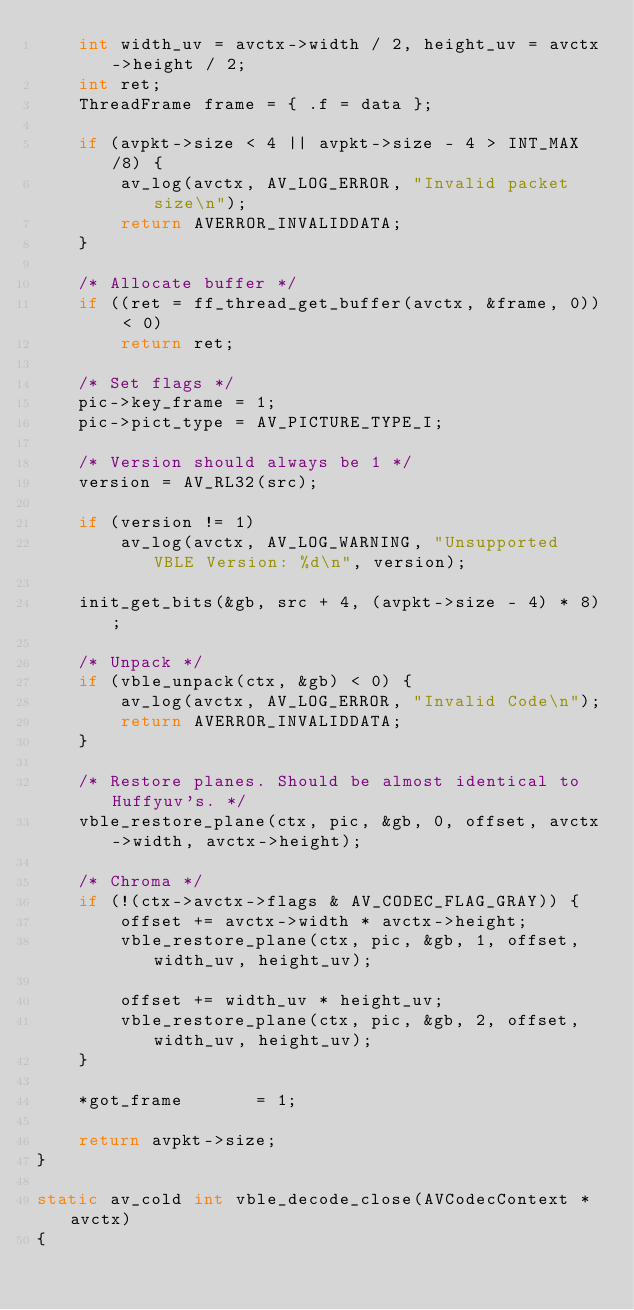Convert code to text. <code><loc_0><loc_0><loc_500><loc_500><_C_>    int width_uv = avctx->width / 2, height_uv = avctx->height / 2;
    int ret;
    ThreadFrame frame = { .f = data };

    if (avpkt->size < 4 || avpkt->size - 4 > INT_MAX/8) {
        av_log(avctx, AV_LOG_ERROR, "Invalid packet size\n");
        return AVERROR_INVALIDDATA;
    }

    /* Allocate buffer */
    if ((ret = ff_thread_get_buffer(avctx, &frame, 0)) < 0)
        return ret;

    /* Set flags */
    pic->key_frame = 1;
    pic->pict_type = AV_PICTURE_TYPE_I;

    /* Version should always be 1 */
    version = AV_RL32(src);

    if (version != 1)
        av_log(avctx, AV_LOG_WARNING, "Unsupported VBLE Version: %d\n", version);

    init_get_bits(&gb, src + 4, (avpkt->size - 4) * 8);

    /* Unpack */
    if (vble_unpack(ctx, &gb) < 0) {
        av_log(avctx, AV_LOG_ERROR, "Invalid Code\n");
        return AVERROR_INVALIDDATA;
    }

    /* Restore planes. Should be almost identical to Huffyuv's. */
    vble_restore_plane(ctx, pic, &gb, 0, offset, avctx->width, avctx->height);

    /* Chroma */
    if (!(ctx->avctx->flags & AV_CODEC_FLAG_GRAY)) {
        offset += avctx->width * avctx->height;
        vble_restore_plane(ctx, pic, &gb, 1, offset, width_uv, height_uv);

        offset += width_uv * height_uv;
        vble_restore_plane(ctx, pic, &gb, 2, offset, width_uv, height_uv);
    }

    *got_frame       = 1;

    return avpkt->size;
}

static av_cold int vble_decode_close(AVCodecContext *avctx)
{</code> 